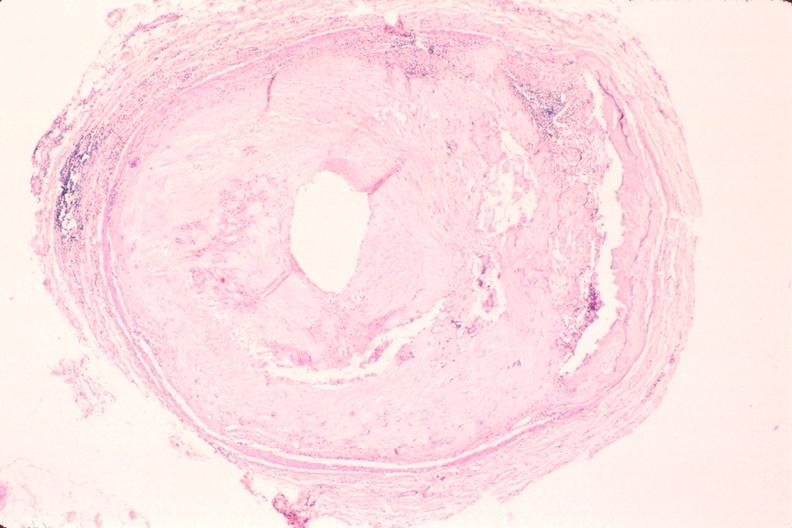does this image show atherosclerosis, right coronary artery?
Answer the question using a single word or phrase. Yes 